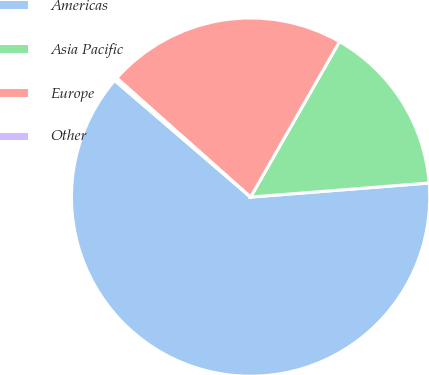Convert chart to OTSL. <chart><loc_0><loc_0><loc_500><loc_500><pie_chart><fcel>Americas<fcel>Asia Pacific<fcel>Europe<fcel>Other<nl><fcel>62.54%<fcel>15.48%<fcel>21.7%<fcel>0.28%<nl></chart> 